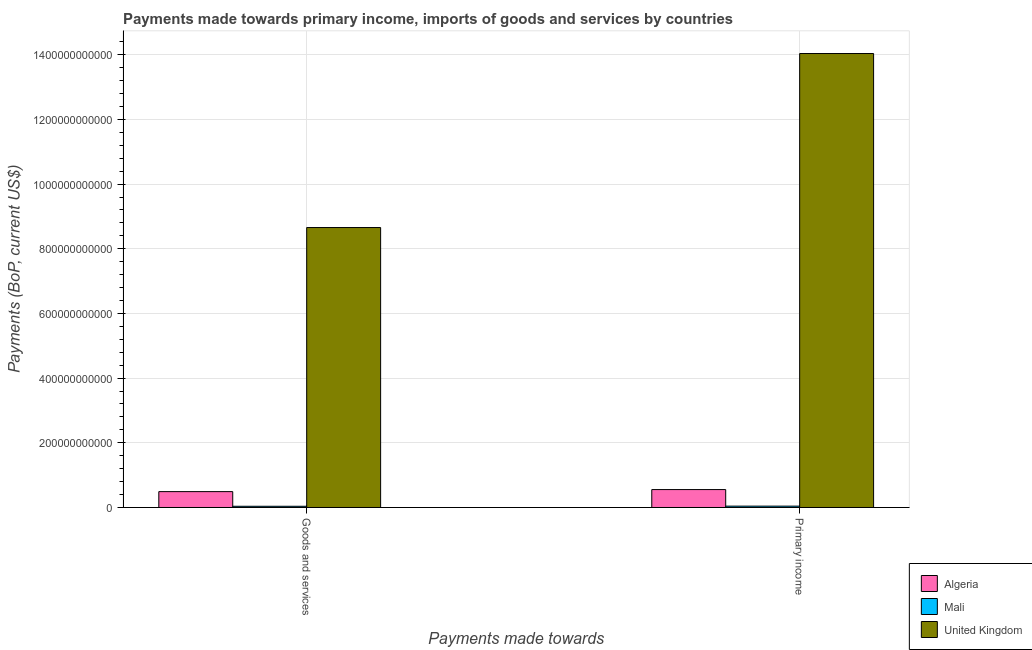How many different coloured bars are there?
Your answer should be compact. 3. Are the number of bars per tick equal to the number of legend labels?
Your answer should be compact. Yes. Are the number of bars on each tick of the X-axis equal?
Provide a succinct answer. Yes. How many bars are there on the 1st tick from the left?
Offer a terse response. 3. How many bars are there on the 2nd tick from the right?
Ensure brevity in your answer.  3. What is the label of the 2nd group of bars from the left?
Ensure brevity in your answer.  Primary income. What is the payments made towards primary income in Algeria?
Keep it short and to the point. 5.54e+1. Across all countries, what is the maximum payments made towards primary income?
Make the answer very short. 1.40e+12. Across all countries, what is the minimum payments made towards goods and services?
Provide a succinct answer. 3.76e+09. In which country was the payments made towards primary income maximum?
Ensure brevity in your answer.  United Kingdom. In which country was the payments made towards goods and services minimum?
Keep it short and to the point. Mali. What is the total payments made towards primary income in the graph?
Ensure brevity in your answer.  1.46e+12. What is the difference between the payments made towards goods and services in Algeria and that in Mali?
Your answer should be compact. 4.53e+1. What is the difference between the payments made towards primary income in Mali and the payments made towards goods and services in Algeria?
Keep it short and to the point. -4.49e+1. What is the average payments made towards goods and services per country?
Your response must be concise. 3.06e+11. What is the difference between the payments made towards goods and services and payments made towards primary income in United Kingdom?
Make the answer very short. -5.38e+11. What is the ratio of the payments made towards goods and services in Algeria to that in Mali?
Ensure brevity in your answer.  13.06. Is the payments made towards goods and services in United Kingdom less than that in Algeria?
Provide a succinct answer. No. In how many countries, is the payments made towards primary income greater than the average payments made towards primary income taken over all countries?
Offer a terse response. 1. What does the 1st bar from the left in Goods and services represents?
Offer a very short reply. Algeria. What is the difference between two consecutive major ticks on the Y-axis?
Offer a very short reply. 2.00e+11. Does the graph contain any zero values?
Keep it short and to the point. No. Does the graph contain grids?
Your answer should be very brief. Yes. How many legend labels are there?
Keep it short and to the point. 3. What is the title of the graph?
Ensure brevity in your answer.  Payments made towards primary income, imports of goods and services by countries. What is the label or title of the X-axis?
Your answer should be very brief. Payments made towards. What is the label or title of the Y-axis?
Your answer should be very brief. Payments (BoP, current US$). What is the Payments (BoP, current US$) of Algeria in Goods and services?
Give a very brief answer. 4.91e+1. What is the Payments (BoP, current US$) in Mali in Goods and services?
Offer a terse response. 3.76e+09. What is the Payments (BoP, current US$) in United Kingdom in Goods and services?
Offer a terse response. 8.66e+11. What is the Payments (BoP, current US$) in Algeria in Primary income?
Keep it short and to the point. 5.54e+1. What is the Payments (BoP, current US$) of Mali in Primary income?
Offer a terse response. 4.17e+09. What is the Payments (BoP, current US$) in United Kingdom in Primary income?
Provide a short and direct response. 1.40e+12. Across all Payments made towards, what is the maximum Payments (BoP, current US$) of Algeria?
Keep it short and to the point. 5.54e+1. Across all Payments made towards, what is the maximum Payments (BoP, current US$) of Mali?
Your response must be concise. 4.17e+09. Across all Payments made towards, what is the maximum Payments (BoP, current US$) in United Kingdom?
Make the answer very short. 1.40e+12. Across all Payments made towards, what is the minimum Payments (BoP, current US$) in Algeria?
Your answer should be very brief. 4.91e+1. Across all Payments made towards, what is the minimum Payments (BoP, current US$) of Mali?
Your answer should be compact. 3.76e+09. Across all Payments made towards, what is the minimum Payments (BoP, current US$) in United Kingdom?
Give a very brief answer. 8.66e+11. What is the total Payments (BoP, current US$) of Algeria in the graph?
Offer a very short reply. 1.04e+11. What is the total Payments (BoP, current US$) of Mali in the graph?
Ensure brevity in your answer.  7.93e+09. What is the total Payments (BoP, current US$) of United Kingdom in the graph?
Ensure brevity in your answer.  2.27e+12. What is the difference between the Payments (BoP, current US$) of Algeria in Goods and services and that in Primary income?
Provide a short and direct response. -6.34e+09. What is the difference between the Payments (BoP, current US$) of Mali in Goods and services and that in Primary income?
Your answer should be very brief. -4.14e+08. What is the difference between the Payments (BoP, current US$) of United Kingdom in Goods and services and that in Primary income?
Provide a succinct answer. -5.38e+11. What is the difference between the Payments (BoP, current US$) in Algeria in Goods and services and the Payments (BoP, current US$) in Mali in Primary income?
Offer a very short reply. 4.49e+1. What is the difference between the Payments (BoP, current US$) in Algeria in Goods and services and the Payments (BoP, current US$) in United Kingdom in Primary income?
Provide a succinct answer. -1.35e+12. What is the difference between the Payments (BoP, current US$) of Mali in Goods and services and the Payments (BoP, current US$) of United Kingdom in Primary income?
Your answer should be compact. -1.40e+12. What is the average Payments (BoP, current US$) in Algeria per Payments made towards?
Provide a succinct answer. 5.22e+1. What is the average Payments (BoP, current US$) in Mali per Payments made towards?
Your response must be concise. 3.96e+09. What is the average Payments (BoP, current US$) of United Kingdom per Payments made towards?
Offer a very short reply. 1.13e+12. What is the difference between the Payments (BoP, current US$) in Algeria and Payments (BoP, current US$) in Mali in Goods and services?
Offer a terse response. 4.53e+1. What is the difference between the Payments (BoP, current US$) in Algeria and Payments (BoP, current US$) in United Kingdom in Goods and services?
Make the answer very short. -8.17e+11. What is the difference between the Payments (BoP, current US$) of Mali and Payments (BoP, current US$) of United Kingdom in Goods and services?
Provide a succinct answer. -8.62e+11. What is the difference between the Payments (BoP, current US$) of Algeria and Payments (BoP, current US$) of Mali in Primary income?
Your response must be concise. 5.12e+1. What is the difference between the Payments (BoP, current US$) in Algeria and Payments (BoP, current US$) in United Kingdom in Primary income?
Provide a succinct answer. -1.35e+12. What is the difference between the Payments (BoP, current US$) of Mali and Payments (BoP, current US$) of United Kingdom in Primary income?
Make the answer very short. -1.40e+12. What is the ratio of the Payments (BoP, current US$) in Algeria in Goods and services to that in Primary income?
Ensure brevity in your answer.  0.89. What is the ratio of the Payments (BoP, current US$) in Mali in Goods and services to that in Primary income?
Offer a very short reply. 0.9. What is the ratio of the Payments (BoP, current US$) in United Kingdom in Goods and services to that in Primary income?
Make the answer very short. 0.62. What is the difference between the highest and the second highest Payments (BoP, current US$) in Algeria?
Keep it short and to the point. 6.34e+09. What is the difference between the highest and the second highest Payments (BoP, current US$) of Mali?
Keep it short and to the point. 4.14e+08. What is the difference between the highest and the second highest Payments (BoP, current US$) in United Kingdom?
Provide a succinct answer. 5.38e+11. What is the difference between the highest and the lowest Payments (BoP, current US$) of Algeria?
Your answer should be very brief. 6.34e+09. What is the difference between the highest and the lowest Payments (BoP, current US$) in Mali?
Ensure brevity in your answer.  4.14e+08. What is the difference between the highest and the lowest Payments (BoP, current US$) of United Kingdom?
Give a very brief answer. 5.38e+11. 